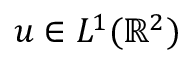Convert formula to latex. <formula><loc_0><loc_0><loc_500><loc_500>u \in L ^ { 1 } ( \mathbb { R } ^ { 2 } )</formula> 